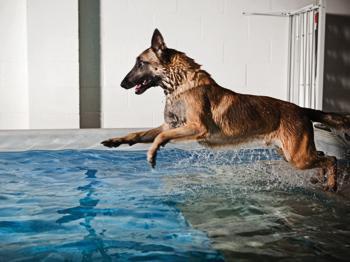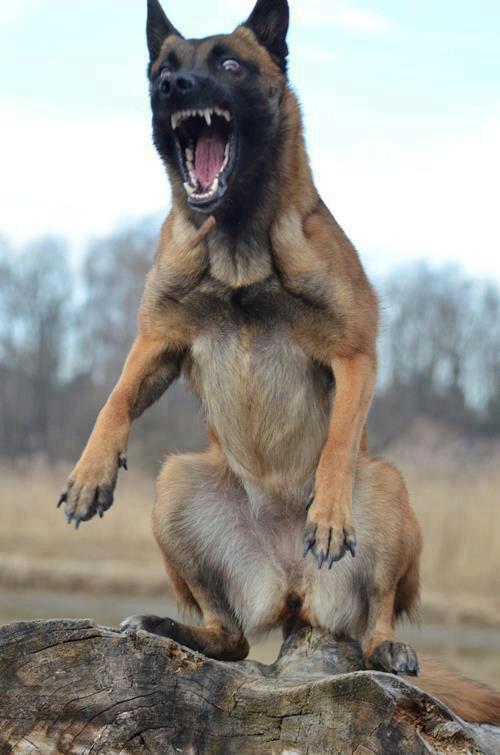The first image is the image on the left, the second image is the image on the right. Given the left and right images, does the statement "A dog is in a jumping pose splashing over water, facing leftward with front paws extended." hold true? Answer yes or no. Yes. The first image is the image on the left, the second image is the image on the right. Considering the images on both sides, is "An image contains a dog jumping in water." valid? Answer yes or no. Yes. 